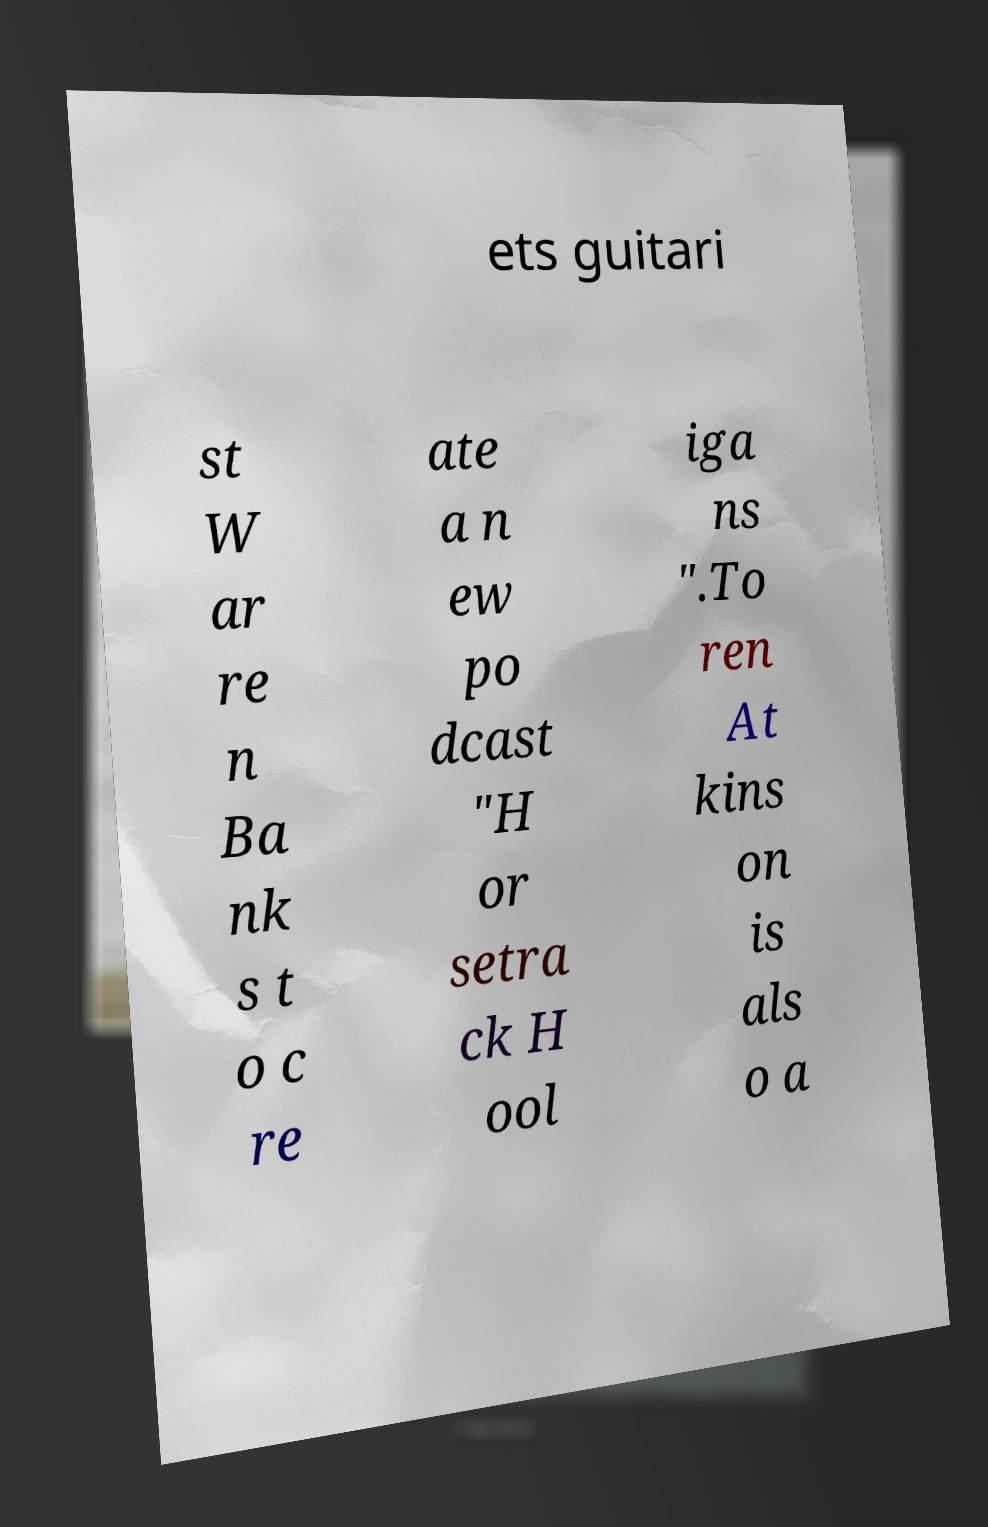Please identify and transcribe the text found in this image. ets guitari st W ar re n Ba nk s t o c re ate a n ew po dcast "H or setra ck H ool iga ns ".To ren At kins on is als o a 